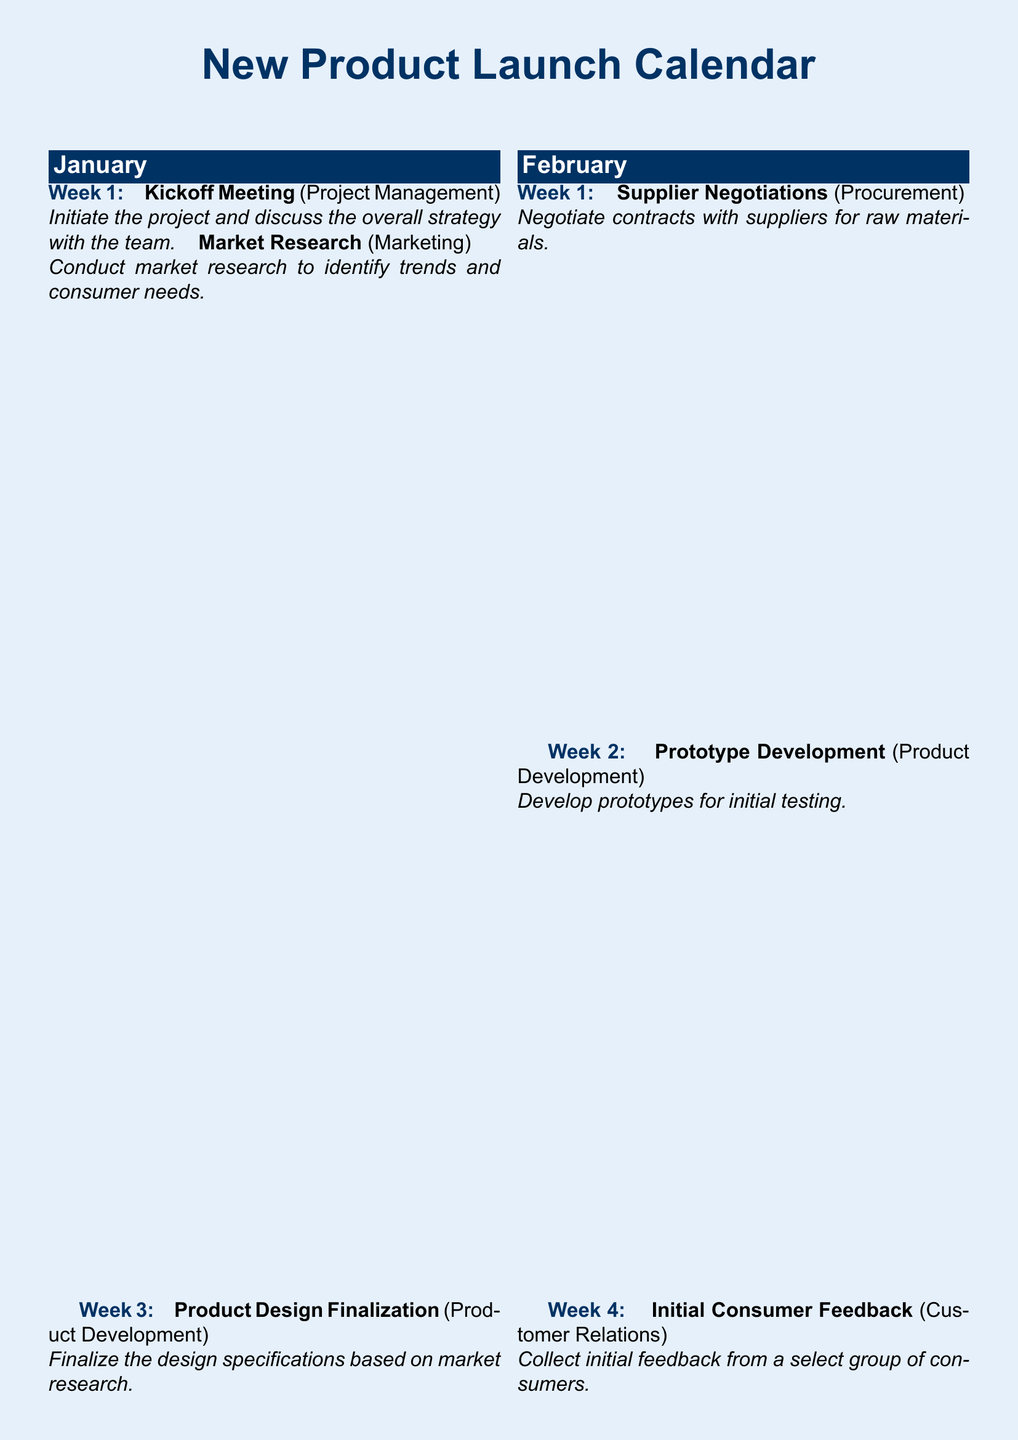What is the date of the official product launch? The official product launch is scheduled for Week 1 of May.
Answer: May, Week 1 Who conducts the market research? The market research is conducted by the Marketing department.
Answer: Marketing How many weeks are allocated for consumer feedback collection after the launch? There is a two-week period for ongoing feedback collection after the launch, scheduled for Week 3 of May.
Answer: 2 weeks What is the focus of the milestone in Week 2 of March? The focus in Week 2 of March is Field Testing.
Answer: Field Testing What event is scheduled for Week 3 of April? A Pre-Launch Event is scheduled for Week 3 of April.
Answer: Pre-Launch Event What is the purpose of the comprehensive feedback evaluation in June? The comprehensive feedback evaluation aims to prepare a report based on the collected consumer feedback.
Answer: Prepare a report During which week is the prototype development planned? Prototype Development is planned for Week 2 of February.
Answer: Week 2 of February What milestone is associated with the procurement department? Supplier Negotiations is the milestone associated with the Procurement department.
Answer: Supplier Negotiations When will the initial consumer feedback be collected? Initial consumer feedback will be collected in Week 4 of February.
Answer: Week 4 of February 